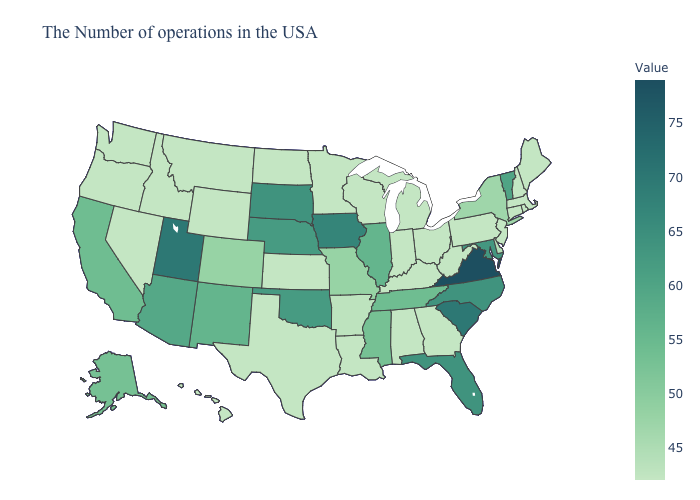Does California have the lowest value in the West?
Quick response, please. No. Does Utah have a higher value than Virginia?
Be succinct. No. Which states have the lowest value in the South?
Concise answer only. West Virginia, Georgia, Kentucky, Alabama, Louisiana, Texas. Does Montana have the highest value in the West?
Write a very short answer. No. Which states have the lowest value in the MidWest?
Be succinct. Ohio, Michigan, Indiana, Wisconsin, Minnesota, Kansas, North Dakota. 